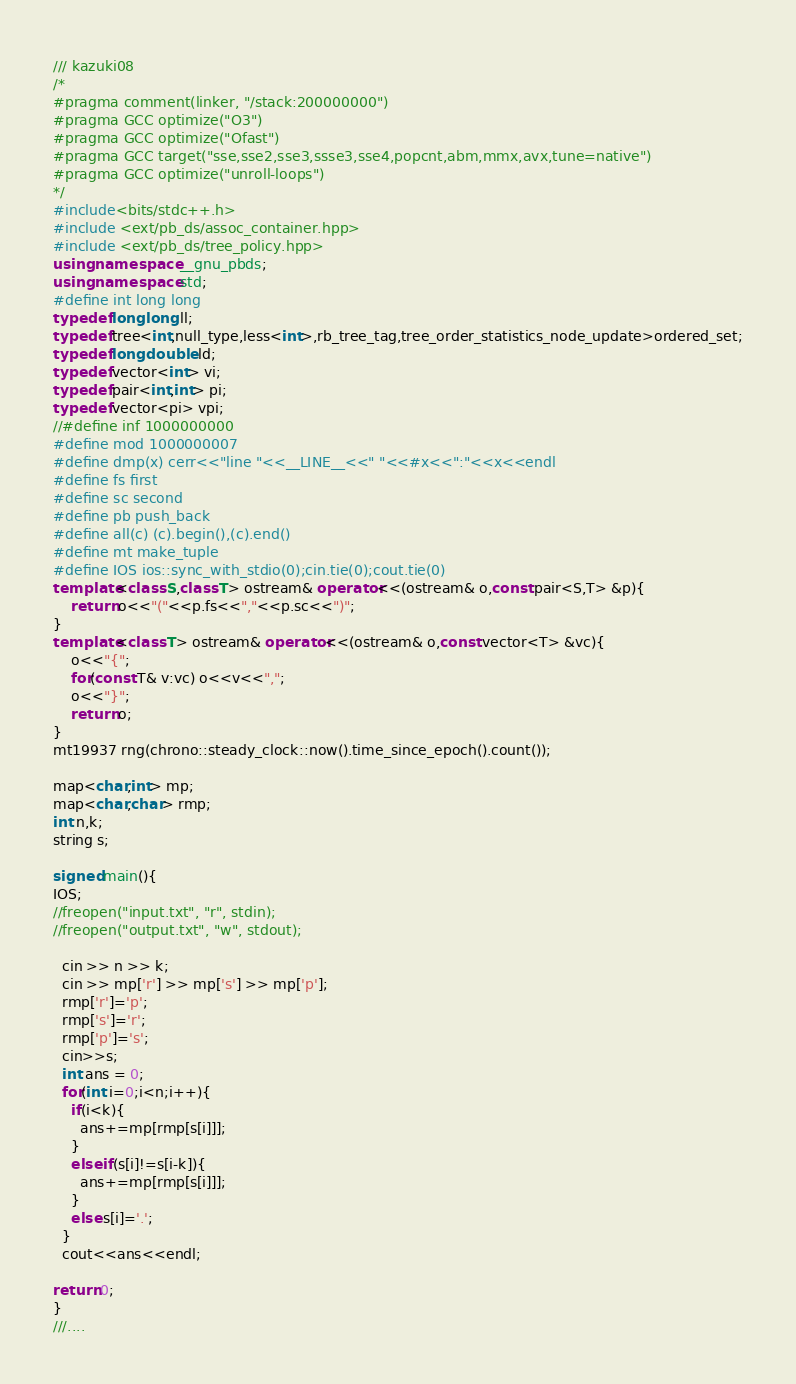Convert code to text. <code><loc_0><loc_0><loc_500><loc_500><_C++_>/// kazuki08
/*
#pragma comment(linker, "/stack:200000000")
#pragma GCC optimize("O3")
#pragma GCC optimize("Ofast")
#pragma GCC target("sse,sse2,sse3,ssse3,sse4,popcnt,abm,mmx,avx,tune=native")
#pragma GCC optimize("unroll-loops")
*/
#include<bits/stdc++.h>
#include <ext/pb_ds/assoc_container.hpp>
#include <ext/pb_ds/tree_policy.hpp>
using namespace __gnu_pbds;
using namespace std;
#define int long long
typedef long long ll;
typedef tree<int,null_type,less<int>,rb_tree_tag,tree_order_statistics_node_update>ordered_set;
typedef long double ld;
typedef vector<int> vi;
typedef pair<int,int> pi;
typedef vector<pi> vpi;
//#define inf 1000000000
#define mod 1000000007
#define dmp(x) cerr<<"line "<<__LINE__<<" "<<#x<<":"<<x<<endl
#define fs first
#define sc second
#define pb push_back
#define all(c) (c).begin(),(c).end()
#define mt make_tuple
#define IOS ios::sync_with_stdio(0);cin.tie(0);cout.tie(0)
template<class S,class T> ostream& operator<<(ostream& o,const pair<S,T> &p){
    return o<<"("<<p.fs<<","<<p.sc<<")";
}
template<class T> ostream& operator<<(ostream& o,const vector<T> &vc){
    o<<"{";
    for(const T& v:vc) o<<v<<",";
    o<<"}";
    return o;
}
mt19937 rng(chrono::steady_clock::now().time_since_epoch().count());

map<char,int> mp;
map<char,char> rmp;
int n,k;
string s;

signed main(){
IOS;
//freopen("input.txt", "r", stdin);
//freopen("output.txt", "w", stdout);
  
  cin >> n >> k;
  cin >> mp['r'] >> mp['s'] >> mp['p'];
  rmp['r']='p';
  rmp['s']='r';
  rmp['p']='s';
  cin>>s;
  int ans = 0;
  for(int i=0;i<n;i++){
    if(i<k){
      ans+=mp[rmp[s[i]]];
    }
    else if(s[i]!=s[i-k]){
      ans+=mp[rmp[s[i]]];
    }
    else s[i]='.';
  }    
  cout<<ans<<endl;

return 0;
}
///....
</code> 